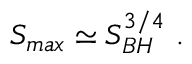<formula> <loc_0><loc_0><loc_500><loc_500>S _ { \max } \simeq S _ { B H } ^ { 3 / 4 } \ .</formula> 